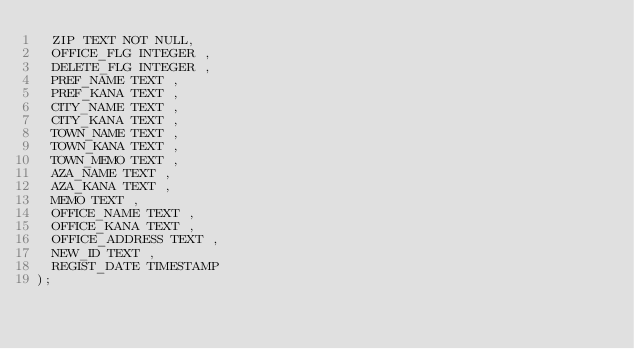Convert code to text. <code><loc_0><loc_0><loc_500><loc_500><_SQL_>  ZIP TEXT NOT NULL,
  OFFICE_FLG INTEGER ,
  DELETE_FLG INTEGER ,
  PREF_NAME TEXT ,
  PREF_KANA TEXT ,
  CITY_NAME TEXT ,
  CITY_KANA TEXT ,
  TOWN_NAME TEXT ,
  TOWN_KANA TEXT ,
  TOWN_MEMO TEXT ,
  AZA_NAME TEXT ,
  AZA_KANA TEXT ,
  MEMO TEXT ,
  OFFICE_NAME TEXT ,
  OFFICE_KANA TEXT ,
  OFFICE_ADDRESS TEXT ,
  NEW_ID TEXT ,
  REGIST_DATE TIMESTAMP 
);</code> 